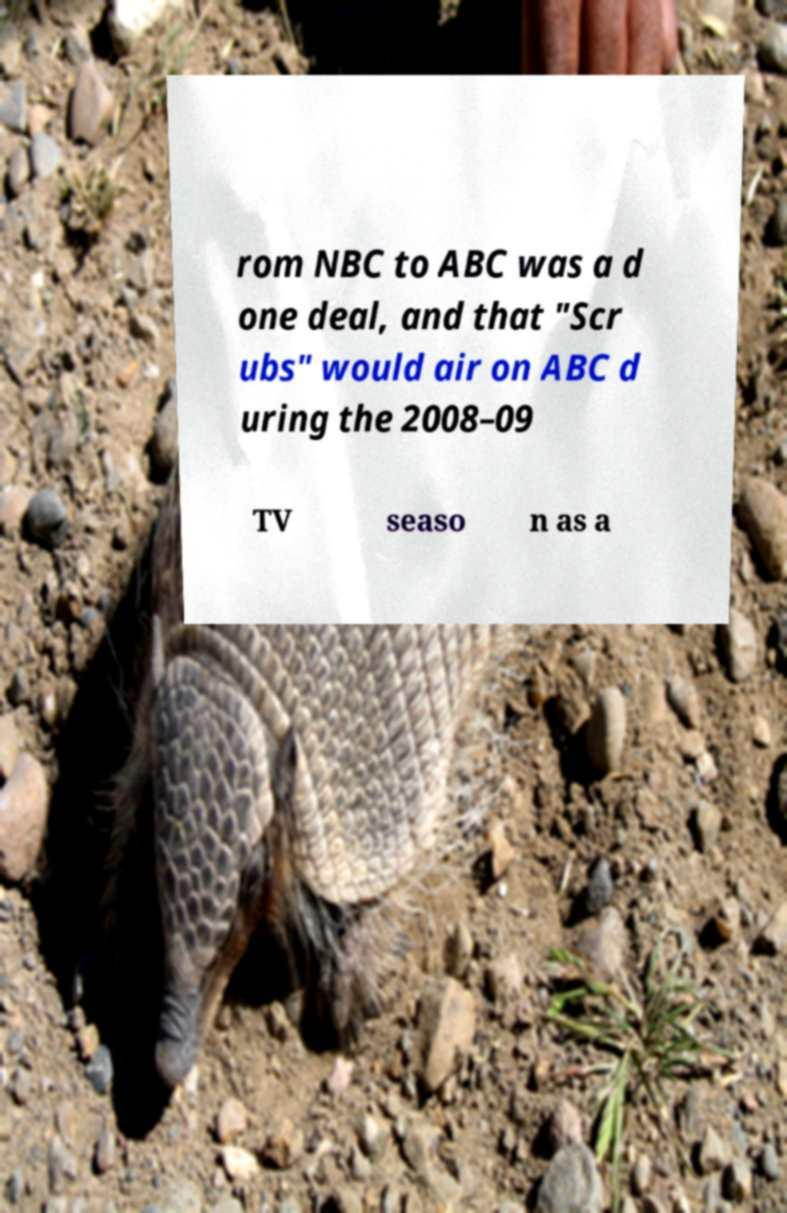What messages or text are displayed in this image? I need them in a readable, typed format. rom NBC to ABC was a d one deal, and that "Scr ubs" would air on ABC d uring the 2008–09 TV seaso n as a 